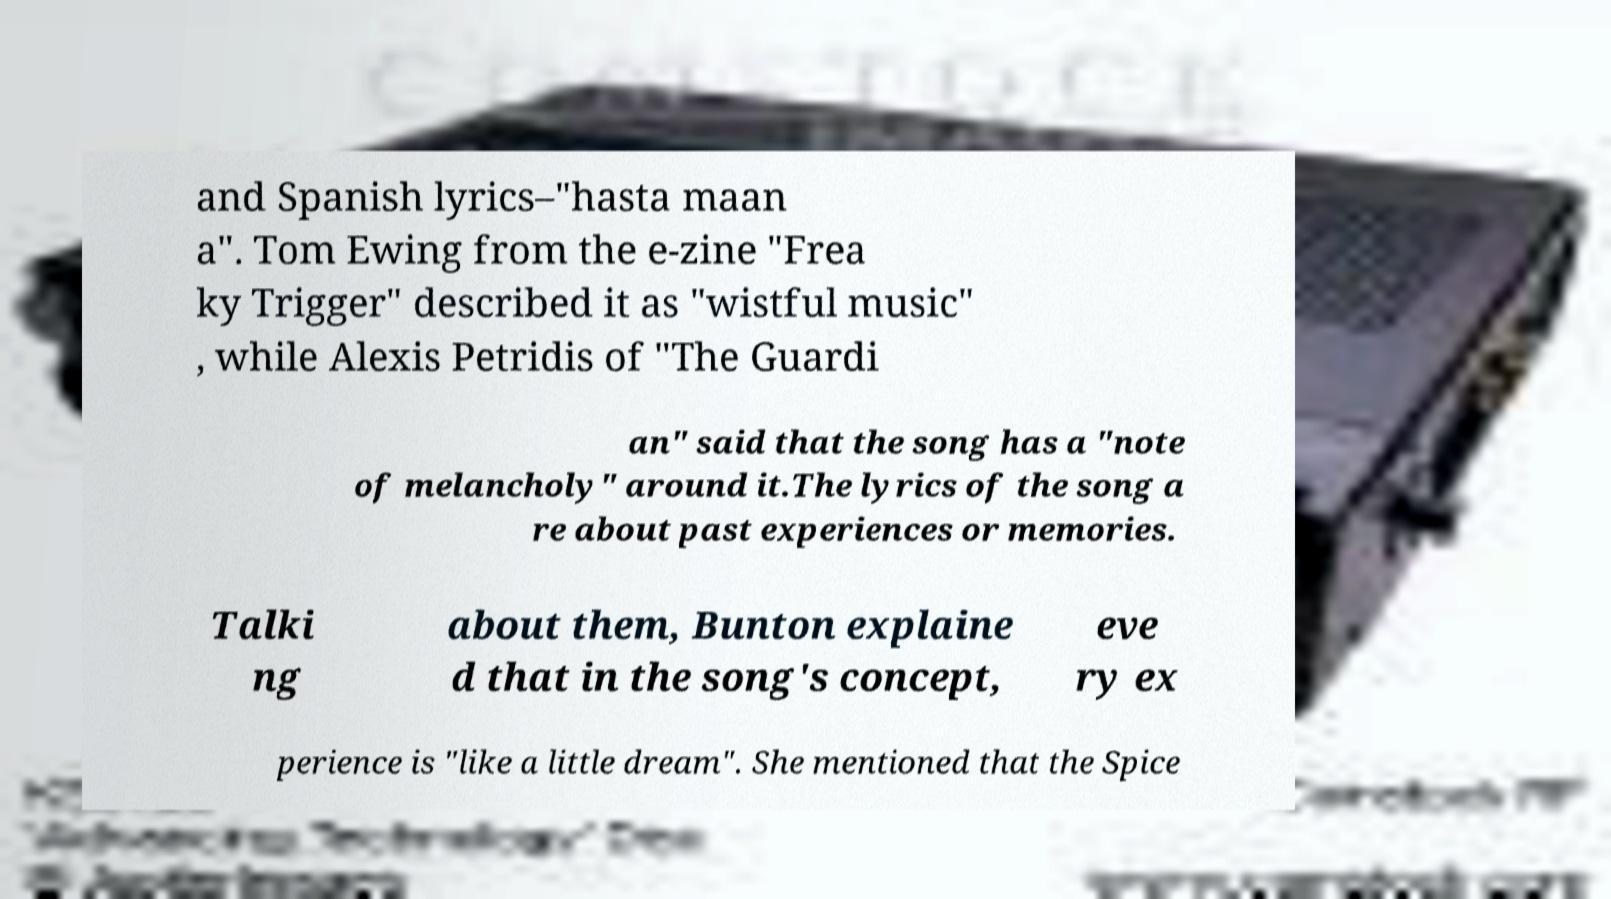Please read and relay the text visible in this image. What does it say? and Spanish lyrics–"hasta maan a". Tom Ewing from the e-zine "Frea ky Trigger" described it as "wistful music" , while Alexis Petridis of "The Guardi an" said that the song has a "note of melancholy" around it.The lyrics of the song a re about past experiences or memories. Talki ng about them, Bunton explaine d that in the song's concept, eve ry ex perience is "like a little dream". She mentioned that the Spice 